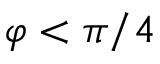Convert formula to latex. <formula><loc_0><loc_0><loc_500><loc_500>\varphi < \pi / 4</formula> 